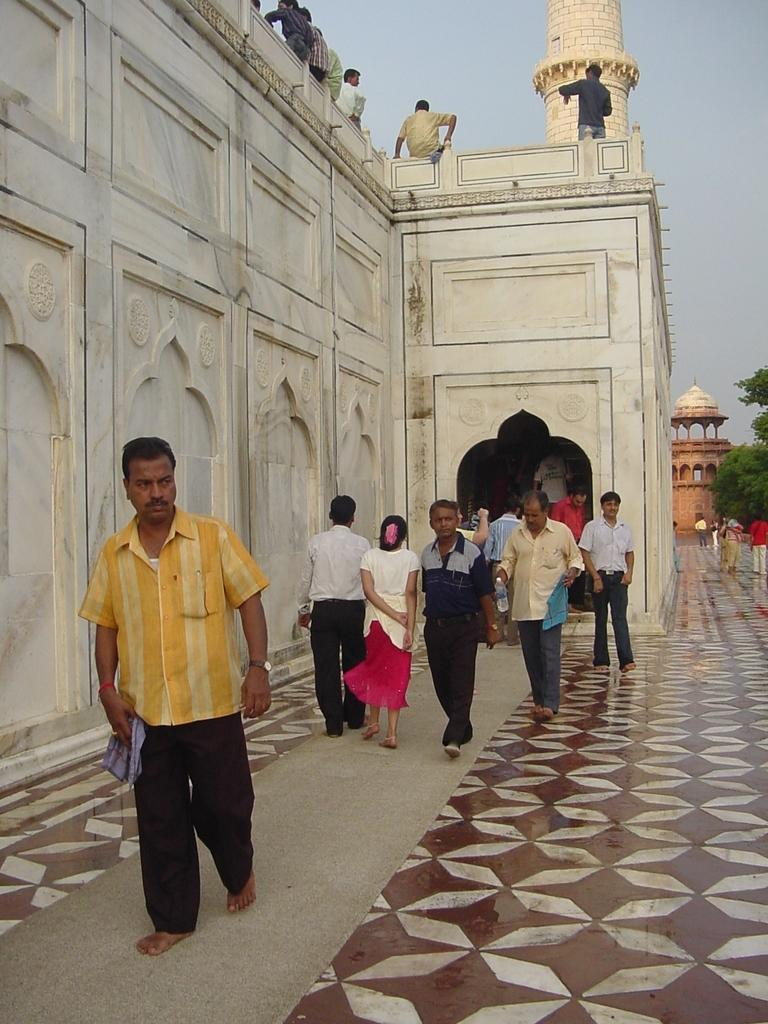What are the people in the image doing? The people in the image are walking on the floor. Where are there people in addition to the floor? There are people on a building in the image. What structure can be seen in the image besides the building? There is a tower visible in the image. What can be seen in the background of the image? There are trees and the sky visible in the background of the image. What type of road can be seen in the image? There is no road present in the image. What question is being asked by the person holding the spade in the image? There is no person holding a spade or asking a question in the image. 